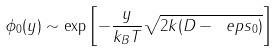Convert formula to latex. <formula><loc_0><loc_0><loc_500><loc_500>\phi _ { 0 } ( y ) \sim \exp \left [ - \frac { y } { k _ { B } T } \sqrt { 2 k ( D - \ e p s _ { 0 } ) } \right ]</formula> 